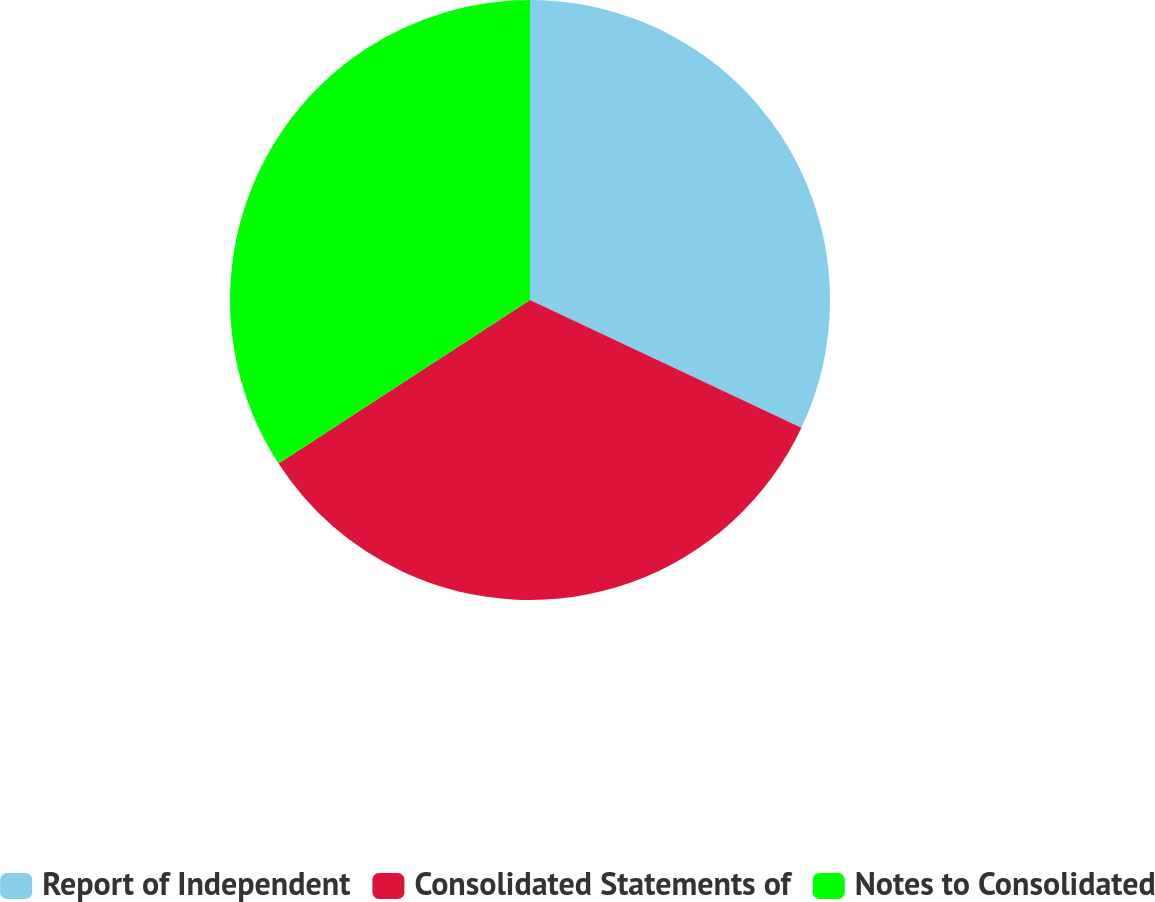Convert chart. <chart><loc_0><loc_0><loc_500><loc_500><pie_chart><fcel>Report of Independent<fcel>Consolidated Statements of<fcel>Notes to Consolidated<nl><fcel>32.0%<fcel>33.82%<fcel>34.18%<nl></chart> 